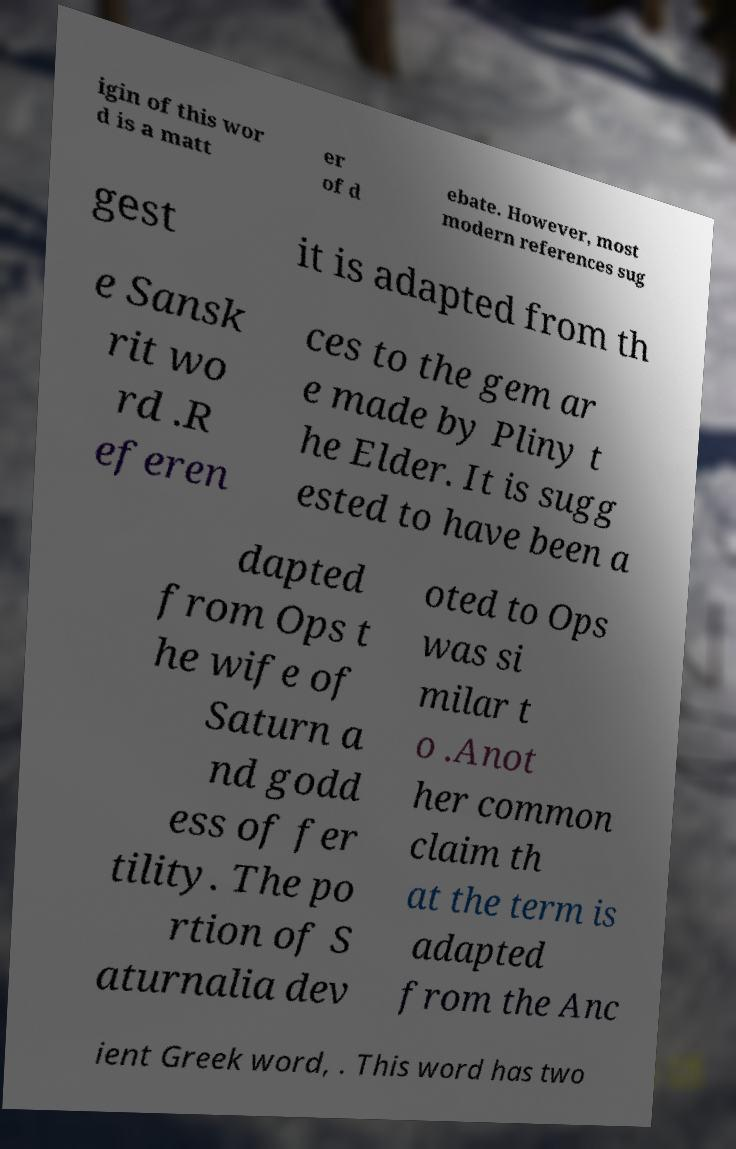Can you read and provide the text displayed in the image?This photo seems to have some interesting text. Can you extract and type it out for me? igin of this wor d is a matt er of d ebate. However, most modern references sug gest it is adapted from th e Sansk rit wo rd .R eferen ces to the gem ar e made by Pliny t he Elder. It is sugg ested to have been a dapted from Ops t he wife of Saturn a nd godd ess of fer tility. The po rtion of S aturnalia dev oted to Ops was si milar t o .Anot her common claim th at the term is adapted from the Anc ient Greek word, . This word has two 